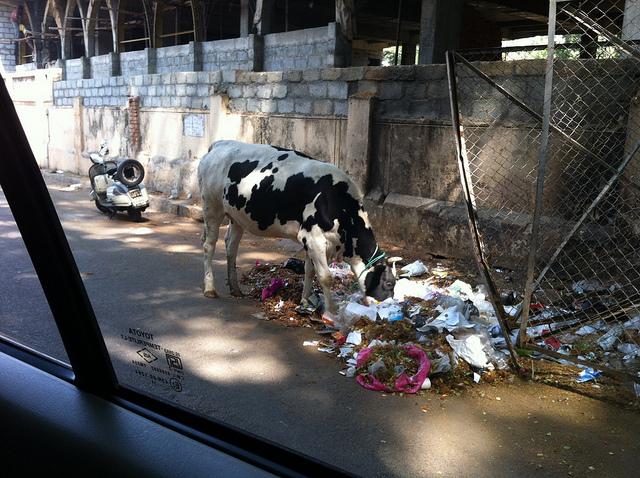Is the cow eating grass or waste scraps?
Keep it brief. Waste scraps. What colors is the cow?
Give a very brief answer. Black and white. Is the cow looking for food?
Concise answer only. Yes. 